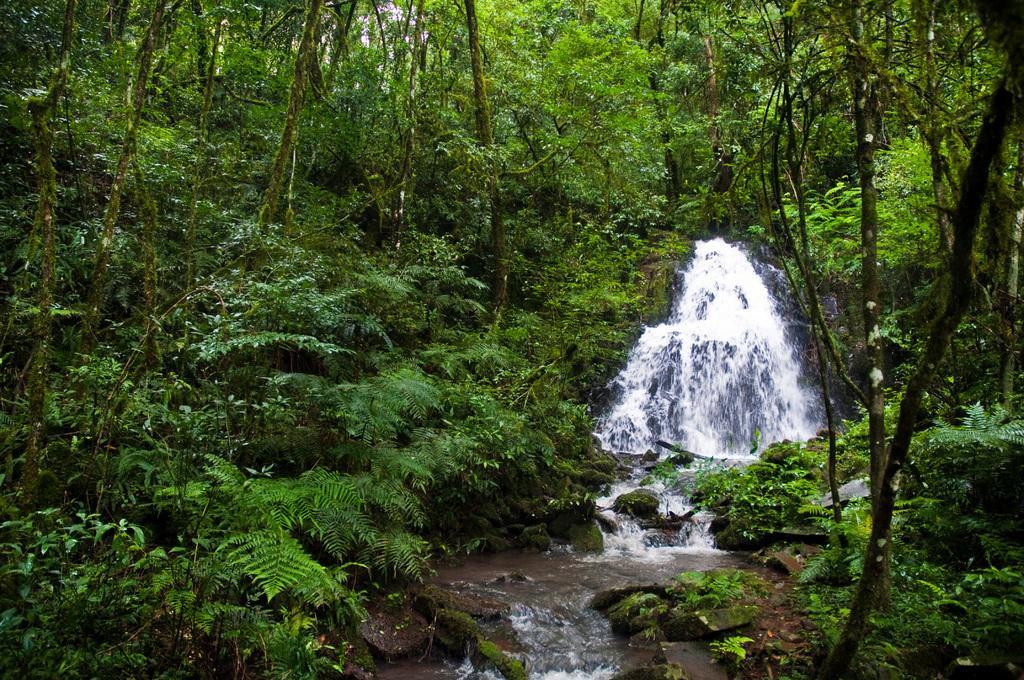Could you give a brief overview of what you see in this image? In this image we can see some trees, plants and water. 